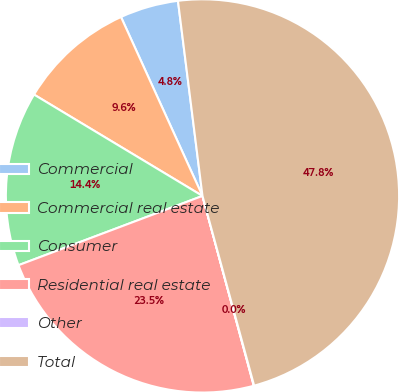Convert chart. <chart><loc_0><loc_0><loc_500><loc_500><pie_chart><fcel>Commercial<fcel>Commercial real estate<fcel>Consumer<fcel>Residential real estate<fcel>Other<fcel>Total<nl><fcel>4.81%<fcel>9.58%<fcel>14.35%<fcel>23.47%<fcel>0.03%<fcel>47.76%<nl></chart> 